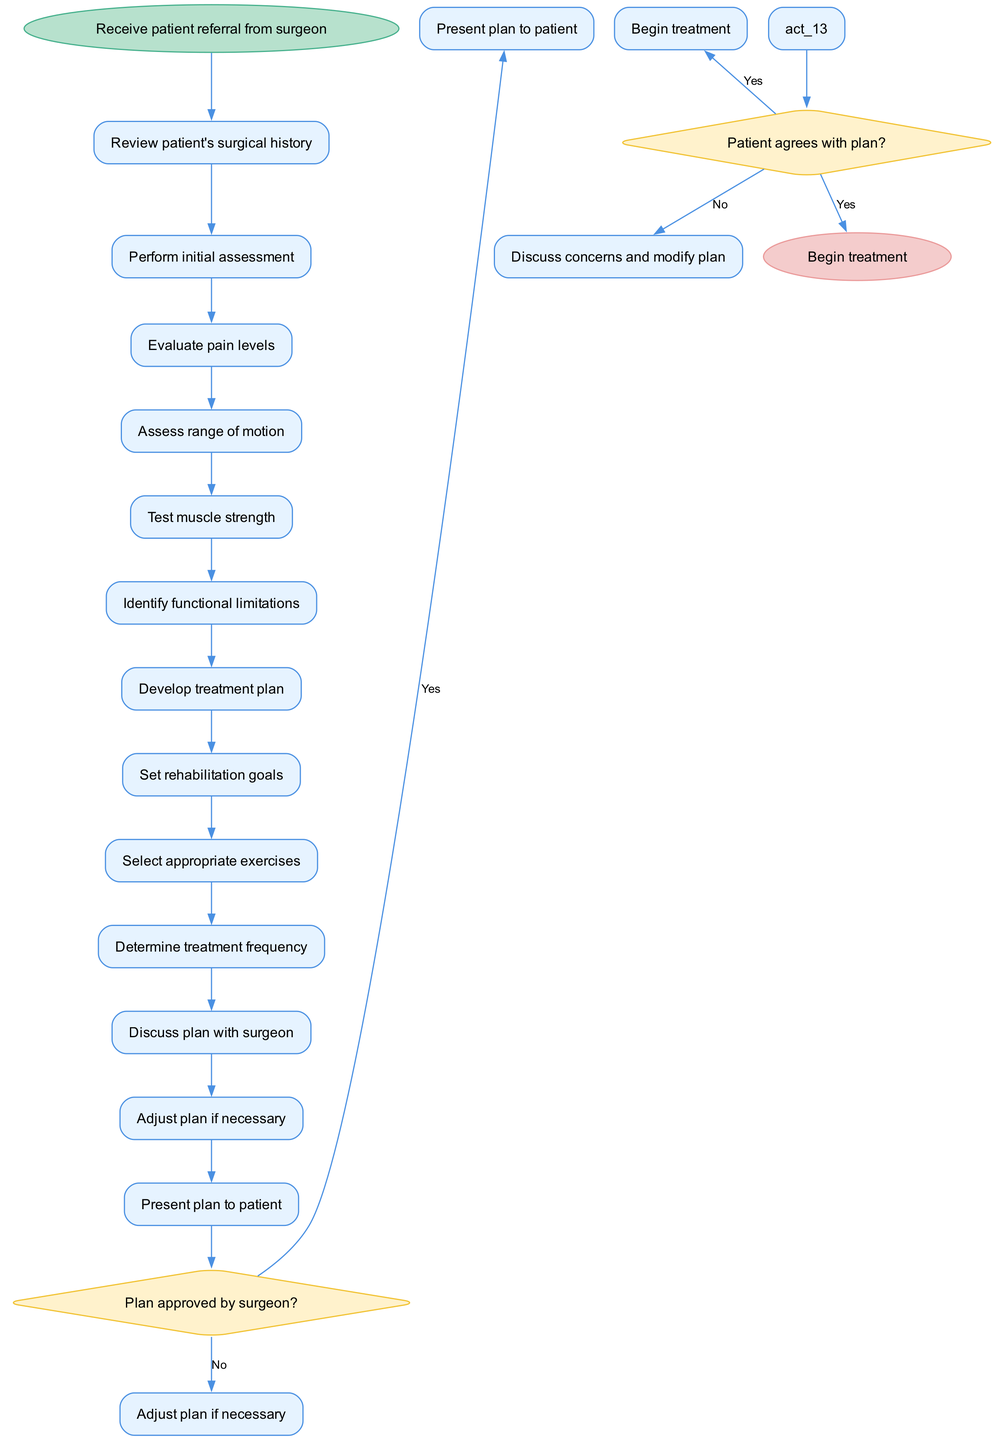What is the initial node of the workflow? The diagram starts with the initial node labeled "Receive patient referral from surgeon." This node indicates the very first step in the workflow process.
Answer: Receive patient referral from surgeon How many activities are listed in the diagram? By counting each individual activity in the activities list from the diagram, we see there are a total of 11 activities.
Answer: 11 What activity follows "Perform initial assessment"? According to the sequence of activities in the diagram, "Evaluate pain levels" directly follows "Perform initial assessment." This shows the order in which the assessments are conducted.
Answer: Evaluate pain levels What is the decision question regarding the surgeon's approval? The decision node specifically addresses whether the "Plan approved by surgeon?" This is crucial as it affects the next step in the workflow.
Answer: Plan approved by surgeon? What happens if the surgeon does not approve the plan? If the plan is not approved by the surgeon, the workflow directs to the action "Adjust plan if necessary," indicating a need for modification before proceeding further.
Answer: Adjust plan if necessary What are the final steps after the treatment plan has been presented? The diagram outlines that after presenting the plan, it leads to querying if the patient agrees with the plan; if yes, the process moves to "Begin treatment." Thus, this step indicates readiness to commence therapy.
Answer: Begin treatment How many decision nodes are present in the diagram? The diagram identifies 2 decision nodes, which help determine the flow of the process based on the responses to specific queries.
Answer: 2 What is the consequence if the patient does not agree with the treatment plan? If the patient does not agree with the plan, the workflow states to "Discuss concerns and modify plan," indicating that further conversation is needed to align with the patient's views before initiation of treatment.
Answer: Discuss concerns and modify plan What is the final node of the workflow? The workflow concludes with the final node titled "Begin treatment," which signifies the ultimate goal of the entire assessment and planning process.
Answer: Begin treatment 